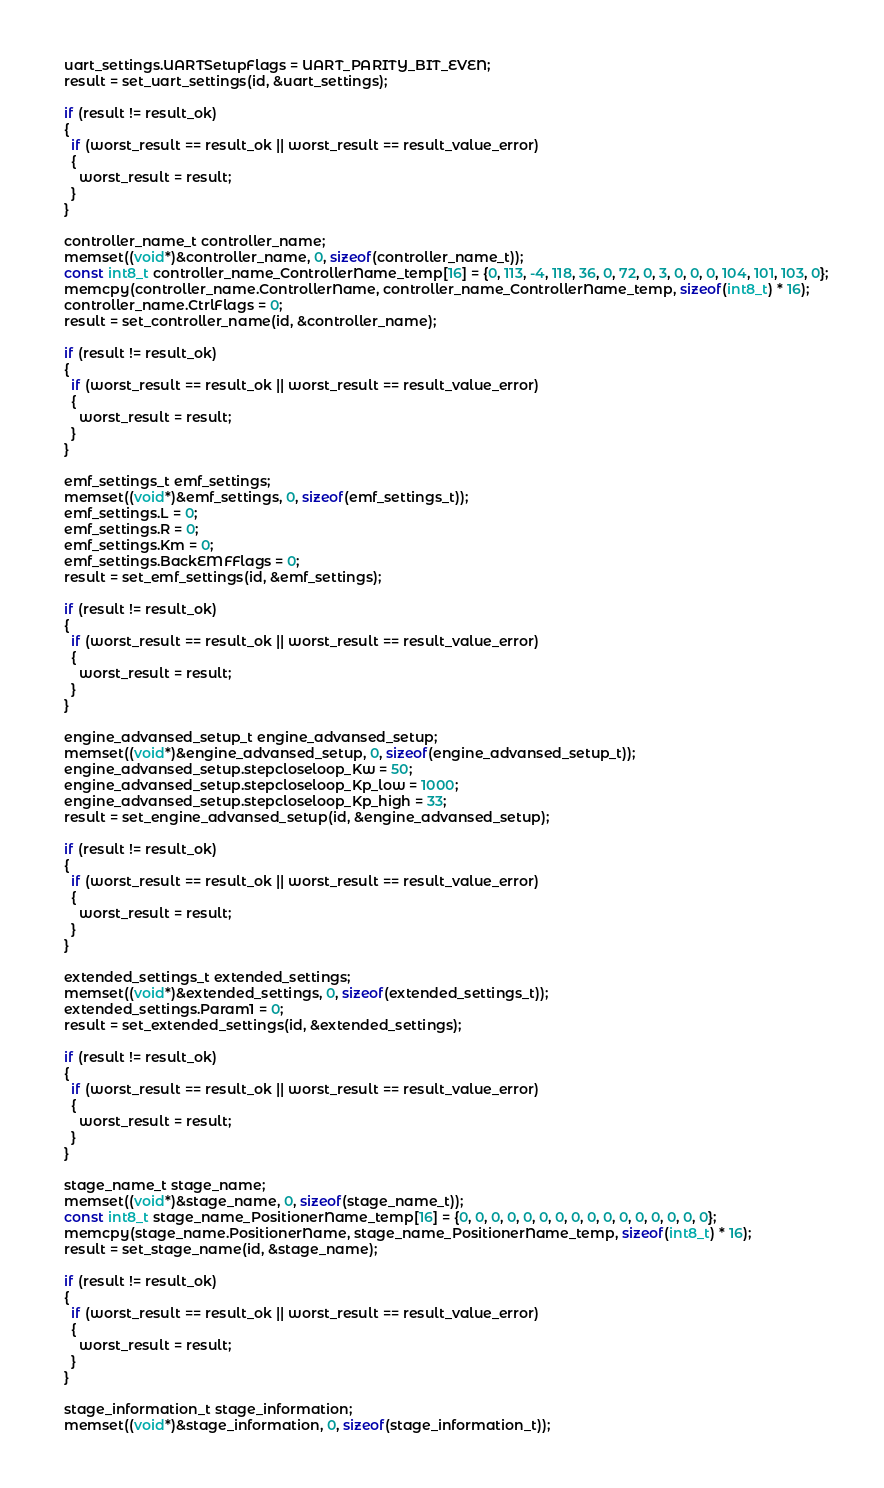<code> <loc_0><loc_0><loc_500><loc_500><_C_>  uart_settings.UARTSetupFlags = UART_PARITY_BIT_EVEN;
  result = set_uart_settings(id, &uart_settings);

  if (result != result_ok)
  {
    if (worst_result == result_ok || worst_result == result_value_error)
    {
      worst_result = result;
    }
  }

  controller_name_t controller_name;
  memset((void*)&controller_name, 0, sizeof(controller_name_t));
  const int8_t controller_name_ControllerName_temp[16] = {0, 113, -4, 118, 36, 0, 72, 0, 3, 0, 0, 0, 104, 101, 103, 0};
  memcpy(controller_name.ControllerName, controller_name_ControllerName_temp, sizeof(int8_t) * 16);
  controller_name.CtrlFlags = 0;
  result = set_controller_name(id, &controller_name);

  if (result != result_ok)
  {
    if (worst_result == result_ok || worst_result == result_value_error)
    {
      worst_result = result;
    }
  }

  emf_settings_t emf_settings;
  memset((void*)&emf_settings, 0, sizeof(emf_settings_t));
  emf_settings.L = 0;
  emf_settings.R = 0;
  emf_settings.Km = 0;
  emf_settings.BackEMFFlags = 0;
  result = set_emf_settings(id, &emf_settings);

  if (result != result_ok)
  {
    if (worst_result == result_ok || worst_result == result_value_error)
    {
      worst_result = result;
    }
  }

  engine_advansed_setup_t engine_advansed_setup;
  memset((void*)&engine_advansed_setup, 0, sizeof(engine_advansed_setup_t));
  engine_advansed_setup.stepcloseloop_Kw = 50;
  engine_advansed_setup.stepcloseloop_Kp_low = 1000;
  engine_advansed_setup.stepcloseloop_Kp_high = 33;
  result = set_engine_advansed_setup(id, &engine_advansed_setup);

  if (result != result_ok)
  {
    if (worst_result == result_ok || worst_result == result_value_error)
    {
      worst_result = result;
    }
  }

  extended_settings_t extended_settings;
  memset((void*)&extended_settings, 0, sizeof(extended_settings_t));
  extended_settings.Param1 = 0;
  result = set_extended_settings(id, &extended_settings);

  if (result != result_ok)
  {
    if (worst_result == result_ok || worst_result == result_value_error)
    {
      worst_result = result;
    }
  }

  stage_name_t stage_name;
  memset((void*)&stage_name, 0, sizeof(stage_name_t));
  const int8_t stage_name_PositionerName_temp[16] = {0, 0, 0, 0, 0, 0, 0, 0, 0, 0, 0, 0, 0, 0, 0, 0};
  memcpy(stage_name.PositionerName, stage_name_PositionerName_temp, sizeof(int8_t) * 16);
  result = set_stage_name(id, &stage_name);

  if (result != result_ok)
  {
    if (worst_result == result_ok || worst_result == result_value_error)
    {
      worst_result = result;
    }
  }

  stage_information_t stage_information;
  memset((void*)&stage_information, 0, sizeof(stage_information_t));</code> 